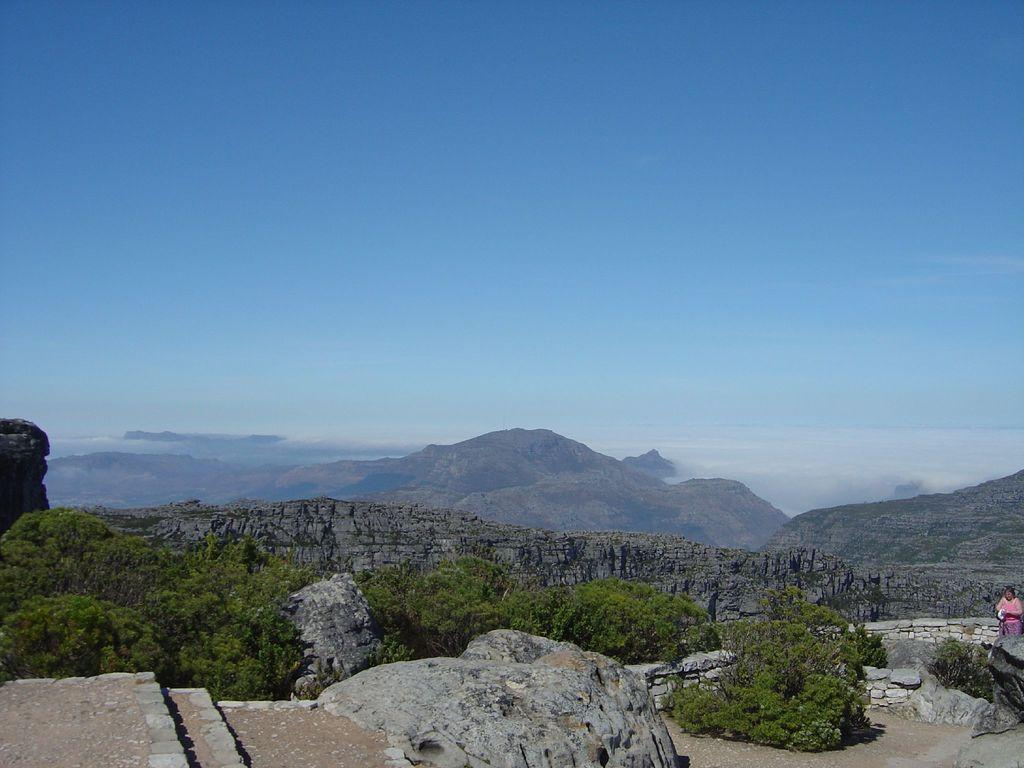What type of natural landscape is depicted in the image? The image features mountains, rocks, and trees, which are all elements of a natural landscape. Can you describe the person in the image? There is a person standing on the right side of the image. What is the condition of the sky in the image? The sky is clear in the image. What type of grape is being harvested by the person in the image? There is no grape or harvesting activity depicted in the image; it features a person standing near a natural landscape. Can you describe the office where the person is working in the image? There is no office present in the image; it is set in a natural landscape with mountains, rocks, and trees. 